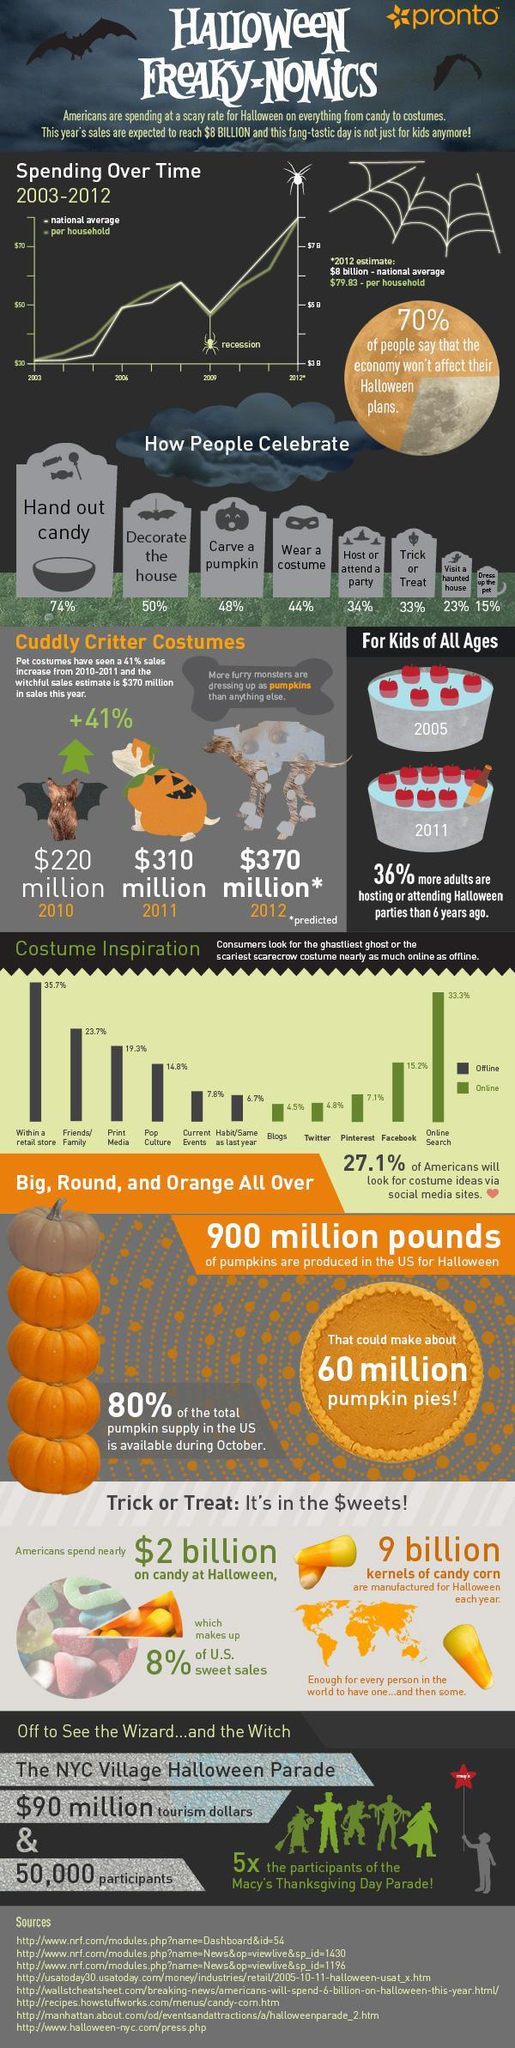How many Americans believe their income shall not count to celebrate Halloween?
Answer the question with a short phrase. 70% When the Halloween celebration of America gained popularity for the first time? 2006 What percentage of people uses Facebook to search for Halloween costume ideas? 15.2% How many people ornament their houses during Halloween? 50% How much is the amount spent by each American families for Halloween? $79.83 What are the characteristics of Halloween pumpkin? Big, Round, and Orange All Over What percentage of Americans make pumpkins with ghoulish faces? 48% Which online platform has the third-highest no of Halloween searches? Pinterest Which is the second online platform listed to search for Halloween ideas? Twitter What percentage of Americans go to ghost house during Halloween? 23% 